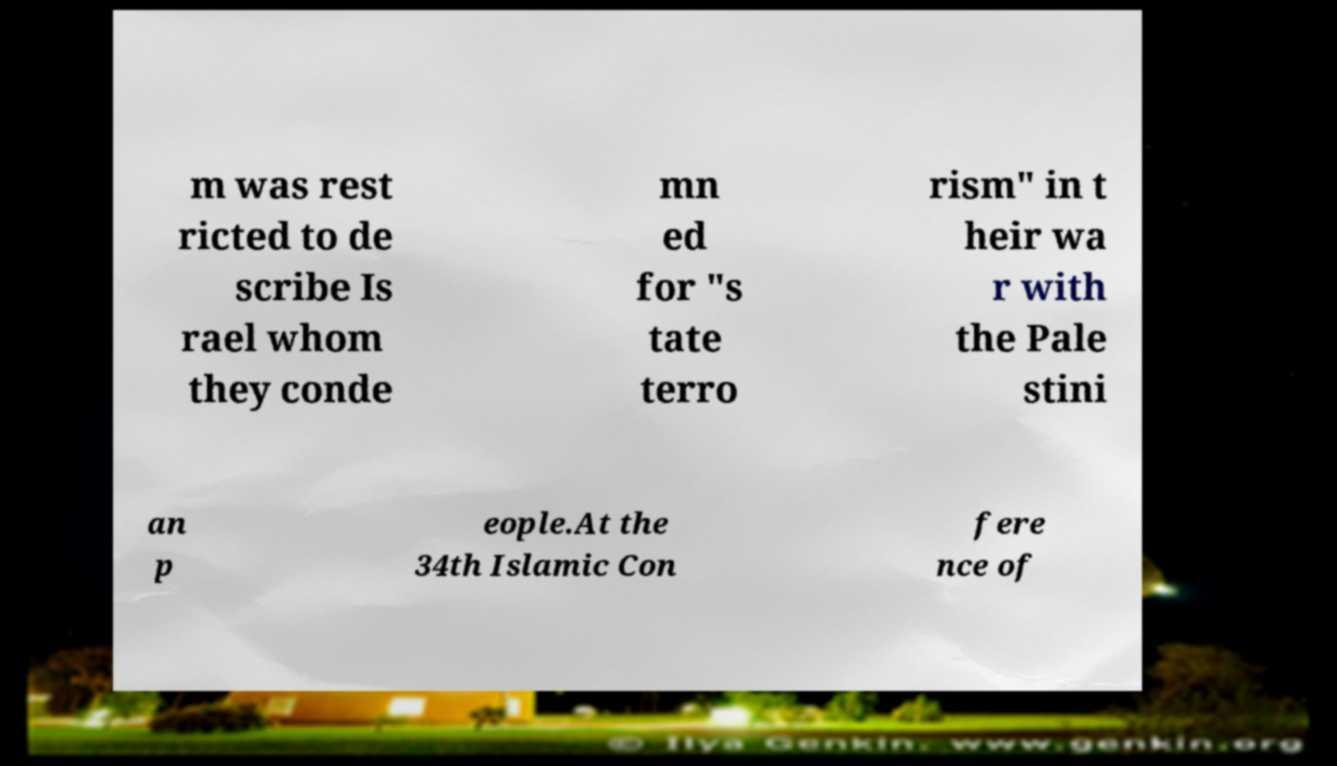What messages or text are displayed in this image? I need them in a readable, typed format. m was rest ricted to de scribe Is rael whom they conde mn ed for "s tate terro rism" in t heir wa r with the Pale stini an p eople.At the 34th Islamic Con fere nce of 